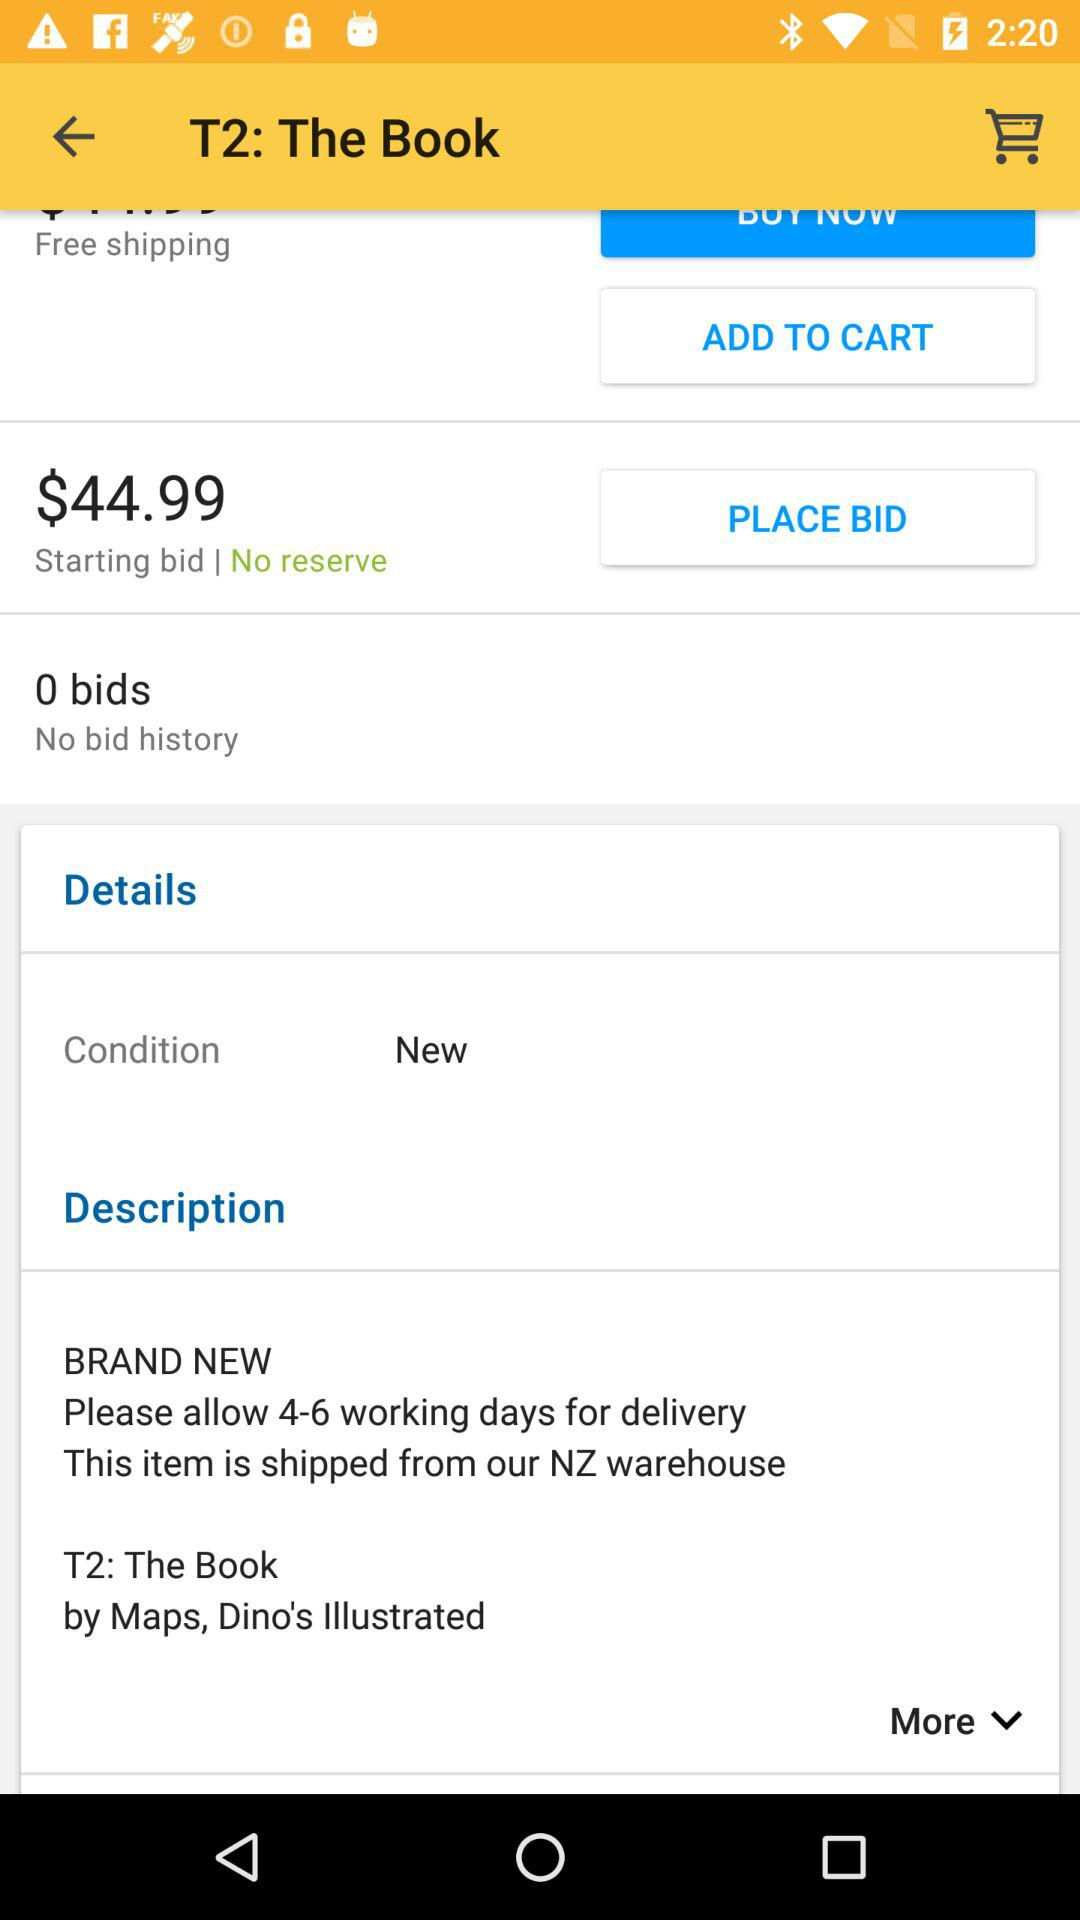What is the starting bid? The starting bid is $44.99. 